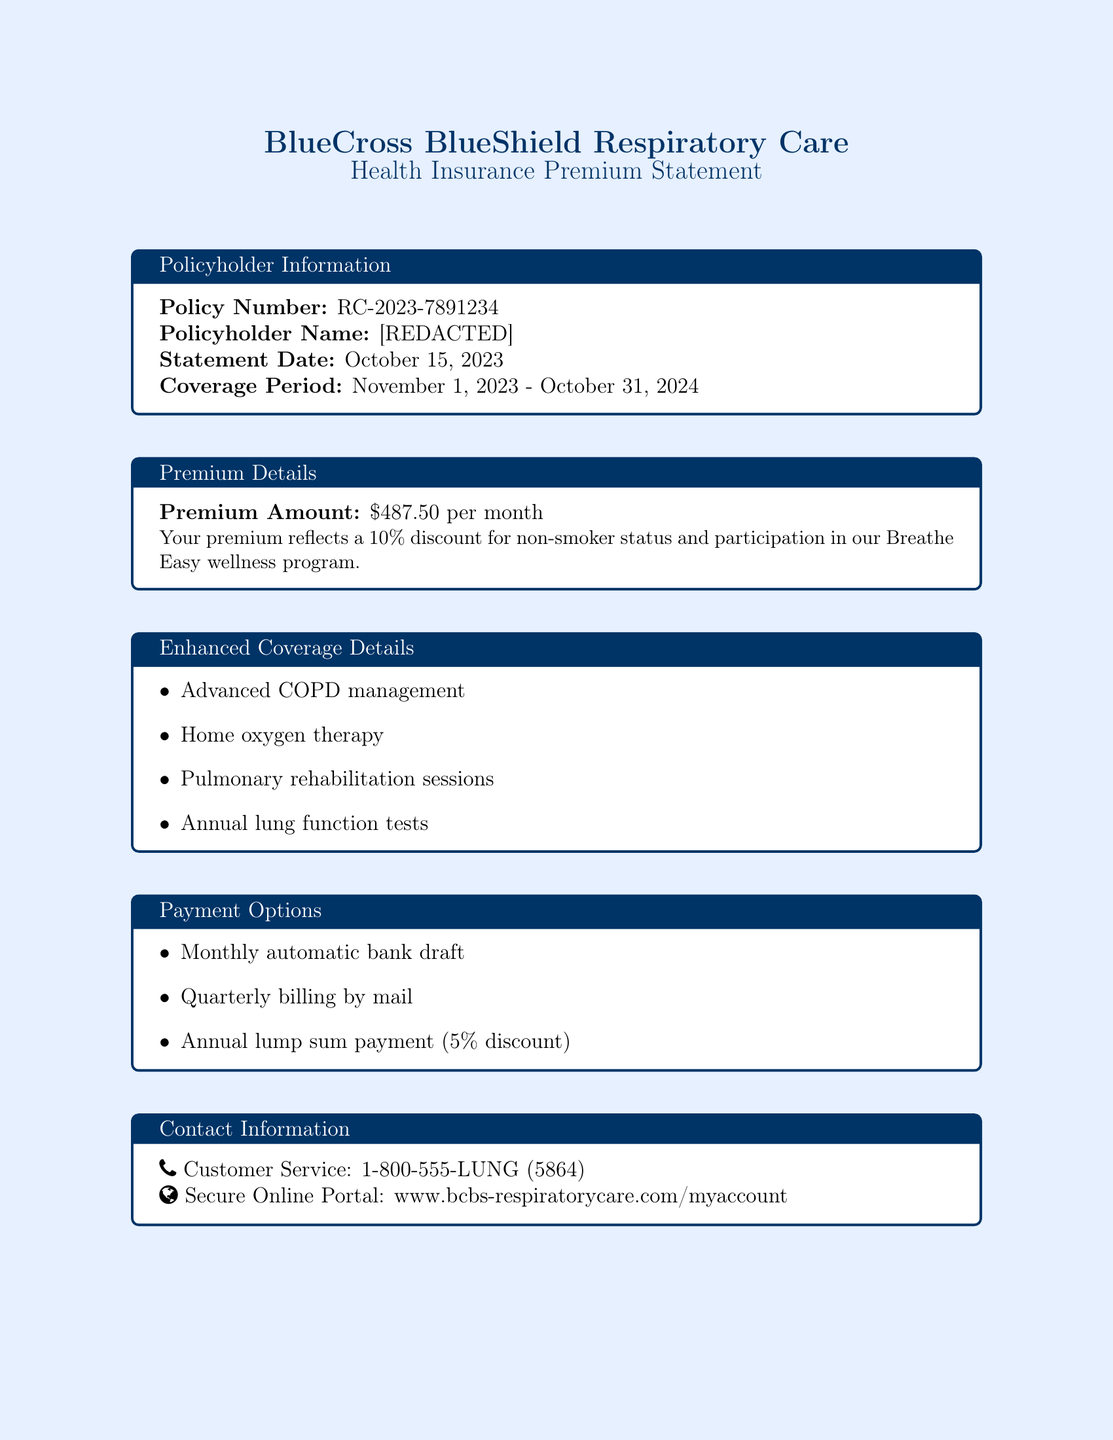What is the policy number? The policy number is explicitly stated in the document under Policyholder Information.
Answer: RC-2023-7891234 What is the monthly premium amount? The monthly premium amount is provided in the Premium Details section of the document.
Answer: $487.50 per month What discount is applied to the premium? The discount for non-smoker status and wellness program participation is mentioned in the Premium Details.
Answer: 10% What is the coverage period? The coverage period is specified in the Policyholder Information section.
Answer: November 1, 2023 - October 31, 2024 List one item included in enhanced coverage. The document lists items under Enhanced Coverage Details; any of those can be included in the answer.
Answer: Advanced COPD management What payment option offers a discount? The document states payment options, and one offers a discount for a lump sum payment.
Answer: Annual lump sum payment (5% discount) Who should the confidentiality statement protect? The confidentiality statement specifies to whom the statement is intended.
Answer: The named policyholder What is the customer service phone number? The document includes contact information for customer service.
Answer: 1-800-555-LUNG (5864) 